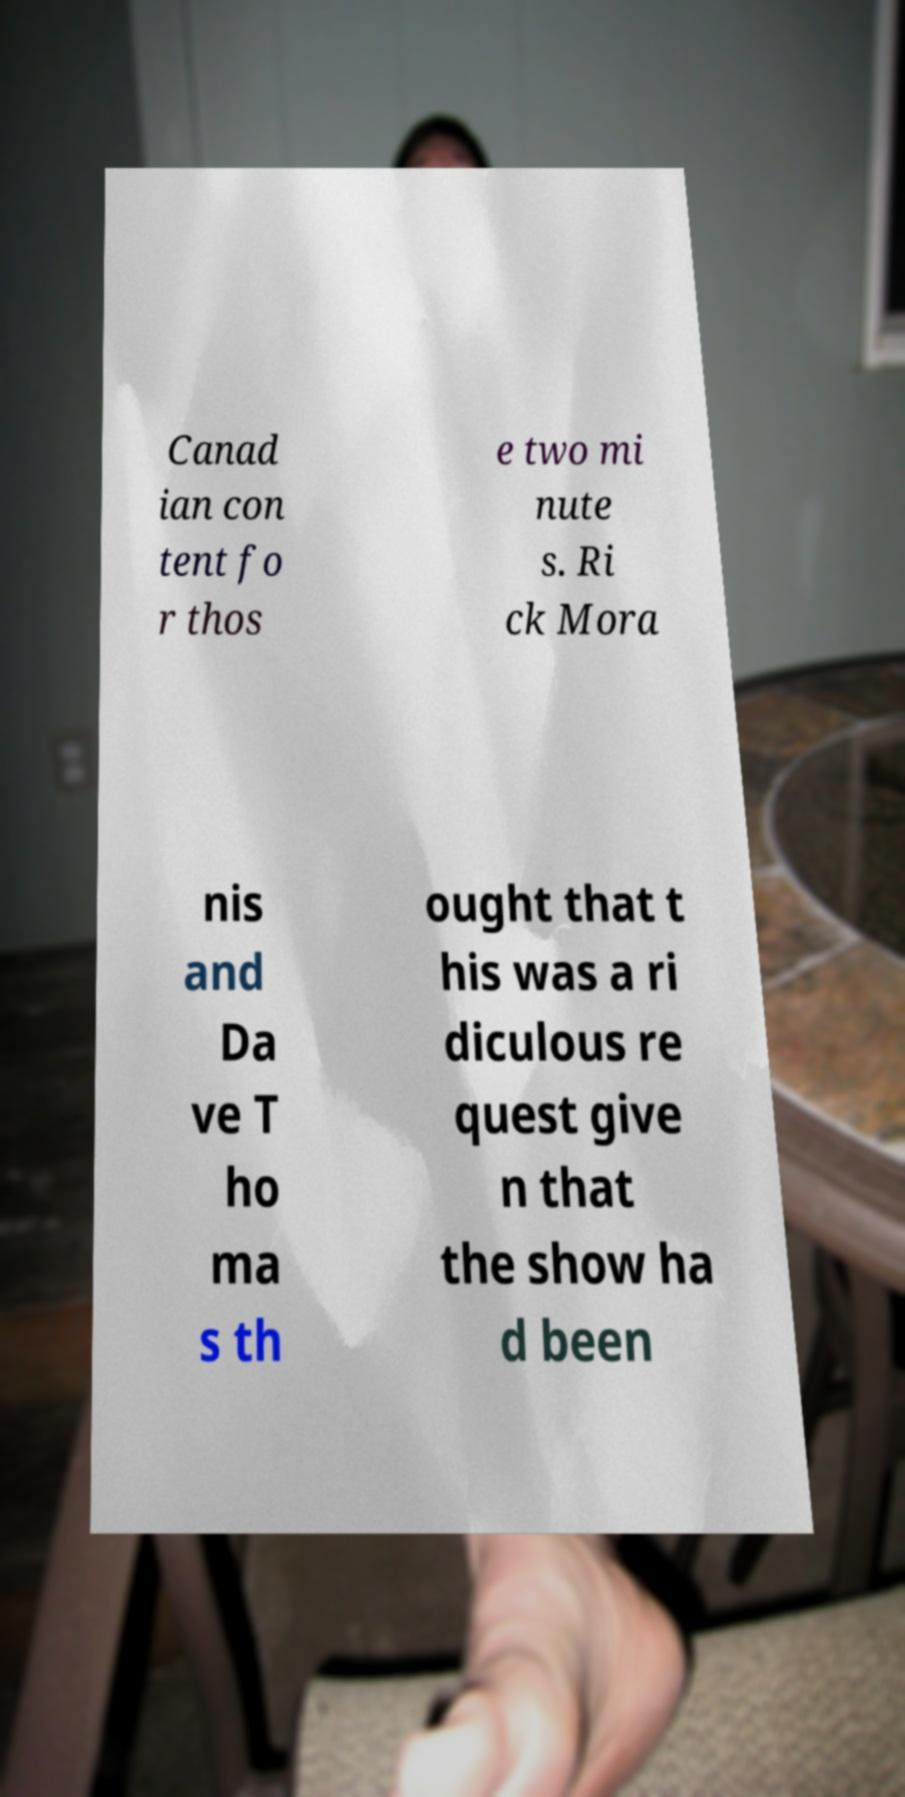There's text embedded in this image that I need extracted. Can you transcribe it verbatim? Canad ian con tent fo r thos e two mi nute s. Ri ck Mora nis and Da ve T ho ma s th ought that t his was a ri diculous re quest give n that the show ha d been 